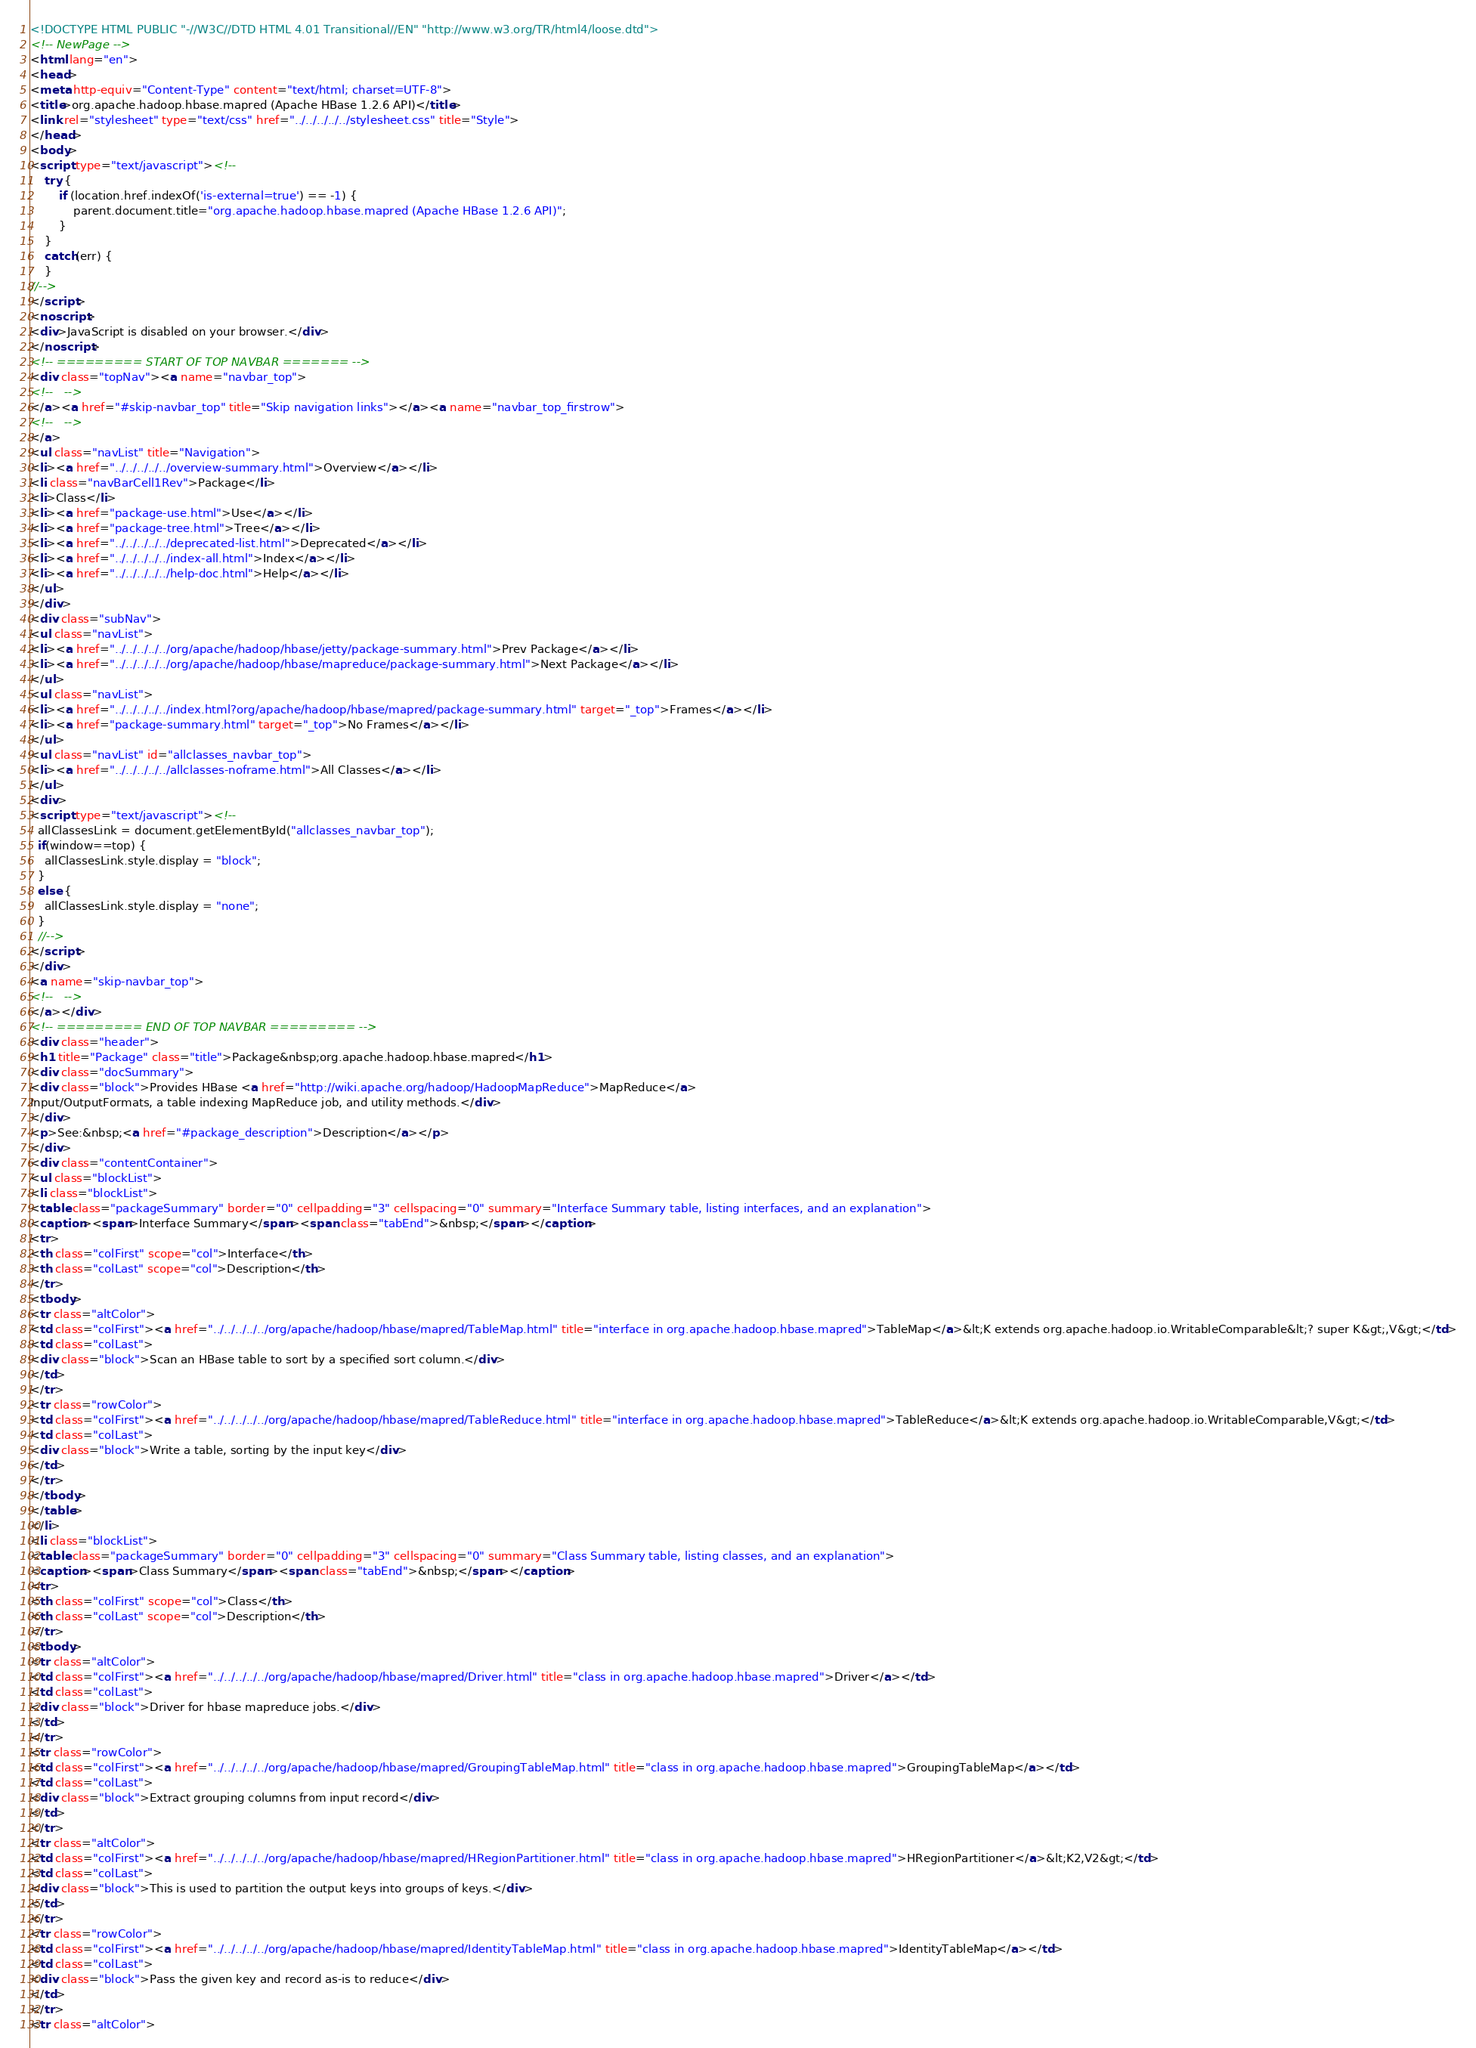<code> <loc_0><loc_0><loc_500><loc_500><_HTML_><!DOCTYPE HTML PUBLIC "-//W3C//DTD HTML 4.01 Transitional//EN" "http://www.w3.org/TR/html4/loose.dtd">
<!-- NewPage -->
<html lang="en">
<head>
<meta http-equiv="Content-Type" content="text/html; charset=UTF-8">
<title>org.apache.hadoop.hbase.mapred (Apache HBase 1.2.6 API)</title>
<link rel="stylesheet" type="text/css" href="../../../../../stylesheet.css" title="Style">
</head>
<body>
<script type="text/javascript"><!--
    try {
        if (location.href.indexOf('is-external=true') == -1) {
            parent.document.title="org.apache.hadoop.hbase.mapred (Apache HBase 1.2.6 API)";
        }
    }
    catch(err) {
    }
//-->
</script>
<noscript>
<div>JavaScript is disabled on your browser.</div>
</noscript>
<!-- ========= START OF TOP NAVBAR ======= -->
<div class="topNav"><a name="navbar_top">
<!--   -->
</a><a href="#skip-navbar_top" title="Skip navigation links"></a><a name="navbar_top_firstrow">
<!--   -->
</a>
<ul class="navList" title="Navigation">
<li><a href="../../../../../overview-summary.html">Overview</a></li>
<li class="navBarCell1Rev">Package</li>
<li>Class</li>
<li><a href="package-use.html">Use</a></li>
<li><a href="package-tree.html">Tree</a></li>
<li><a href="../../../../../deprecated-list.html">Deprecated</a></li>
<li><a href="../../../../../index-all.html">Index</a></li>
<li><a href="../../../../../help-doc.html">Help</a></li>
</ul>
</div>
<div class="subNav">
<ul class="navList">
<li><a href="../../../../../org/apache/hadoop/hbase/jetty/package-summary.html">Prev Package</a></li>
<li><a href="../../../../../org/apache/hadoop/hbase/mapreduce/package-summary.html">Next Package</a></li>
</ul>
<ul class="navList">
<li><a href="../../../../../index.html?org/apache/hadoop/hbase/mapred/package-summary.html" target="_top">Frames</a></li>
<li><a href="package-summary.html" target="_top">No Frames</a></li>
</ul>
<ul class="navList" id="allclasses_navbar_top">
<li><a href="../../../../../allclasses-noframe.html">All Classes</a></li>
</ul>
<div>
<script type="text/javascript"><!--
  allClassesLink = document.getElementById("allclasses_navbar_top");
  if(window==top) {
    allClassesLink.style.display = "block";
  }
  else {
    allClassesLink.style.display = "none";
  }
  //-->
</script>
</div>
<a name="skip-navbar_top">
<!--   -->
</a></div>
<!-- ========= END OF TOP NAVBAR ========= -->
<div class="header">
<h1 title="Package" class="title">Package&nbsp;org.apache.hadoop.hbase.mapred</h1>
<div class="docSummary">
<div class="block">Provides HBase <a href="http://wiki.apache.org/hadoop/HadoopMapReduce">MapReduce</a>
Input/OutputFormats, a table indexing MapReduce job, and utility methods.</div>
</div>
<p>See:&nbsp;<a href="#package_description">Description</a></p>
</div>
<div class="contentContainer">
<ul class="blockList">
<li class="blockList">
<table class="packageSummary" border="0" cellpadding="3" cellspacing="0" summary="Interface Summary table, listing interfaces, and an explanation">
<caption><span>Interface Summary</span><span class="tabEnd">&nbsp;</span></caption>
<tr>
<th class="colFirst" scope="col">Interface</th>
<th class="colLast" scope="col">Description</th>
</tr>
<tbody>
<tr class="altColor">
<td class="colFirst"><a href="../../../../../org/apache/hadoop/hbase/mapred/TableMap.html" title="interface in org.apache.hadoop.hbase.mapred">TableMap</a>&lt;K extends org.apache.hadoop.io.WritableComparable&lt;? super K&gt;,V&gt;</td>
<td class="colLast">
<div class="block">Scan an HBase table to sort by a specified sort column.</div>
</td>
</tr>
<tr class="rowColor">
<td class="colFirst"><a href="../../../../../org/apache/hadoop/hbase/mapred/TableReduce.html" title="interface in org.apache.hadoop.hbase.mapred">TableReduce</a>&lt;K extends org.apache.hadoop.io.WritableComparable,V&gt;</td>
<td class="colLast">
<div class="block">Write a table, sorting by the input key</div>
</td>
</tr>
</tbody>
</table>
</li>
<li class="blockList">
<table class="packageSummary" border="0" cellpadding="3" cellspacing="0" summary="Class Summary table, listing classes, and an explanation">
<caption><span>Class Summary</span><span class="tabEnd">&nbsp;</span></caption>
<tr>
<th class="colFirst" scope="col">Class</th>
<th class="colLast" scope="col">Description</th>
</tr>
<tbody>
<tr class="altColor">
<td class="colFirst"><a href="../../../../../org/apache/hadoop/hbase/mapred/Driver.html" title="class in org.apache.hadoop.hbase.mapred">Driver</a></td>
<td class="colLast">
<div class="block">Driver for hbase mapreduce jobs.</div>
</td>
</tr>
<tr class="rowColor">
<td class="colFirst"><a href="../../../../../org/apache/hadoop/hbase/mapred/GroupingTableMap.html" title="class in org.apache.hadoop.hbase.mapred">GroupingTableMap</a></td>
<td class="colLast">
<div class="block">Extract grouping columns from input record</div>
</td>
</tr>
<tr class="altColor">
<td class="colFirst"><a href="../../../../../org/apache/hadoop/hbase/mapred/HRegionPartitioner.html" title="class in org.apache.hadoop.hbase.mapred">HRegionPartitioner</a>&lt;K2,V2&gt;</td>
<td class="colLast">
<div class="block">This is used to partition the output keys into groups of keys.</div>
</td>
</tr>
<tr class="rowColor">
<td class="colFirst"><a href="../../../../../org/apache/hadoop/hbase/mapred/IdentityTableMap.html" title="class in org.apache.hadoop.hbase.mapred">IdentityTableMap</a></td>
<td class="colLast">
<div class="block">Pass the given key and record as-is to reduce</div>
</td>
</tr>
<tr class="altColor"></code> 